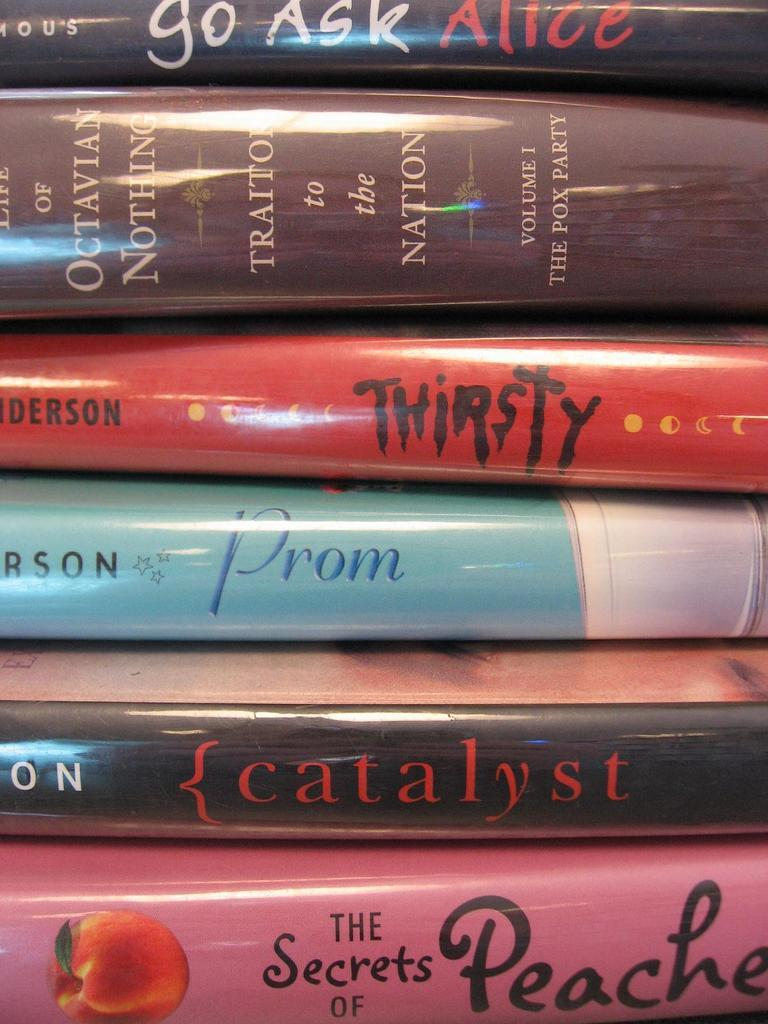<image>
Summarize the visual content of the image. Red book titled "Thirsty" in between other books. 